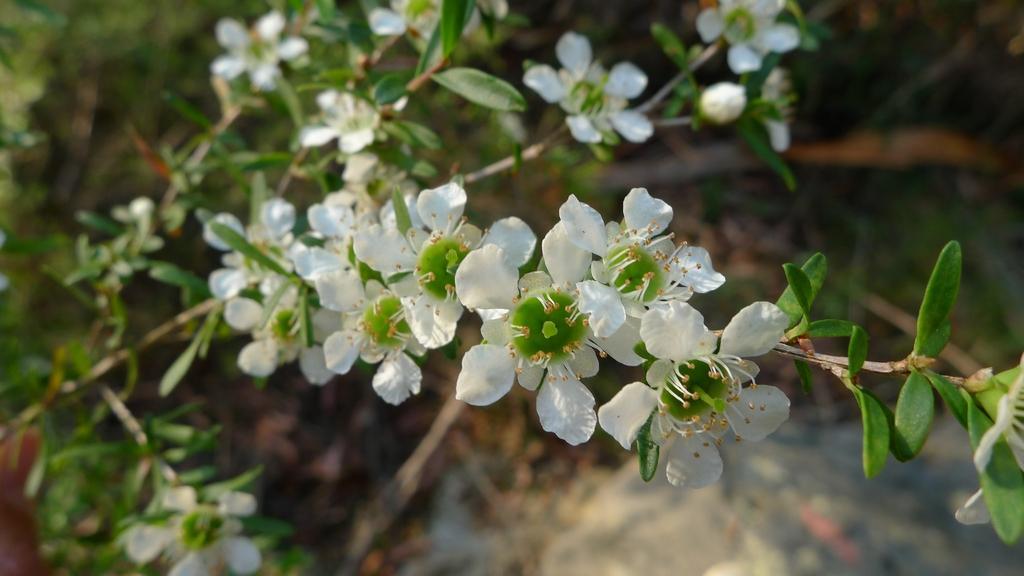Could you give a brief overview of what you see in this image? In this picture there is a white color flowers on the plant. Behind there is a blur background. 